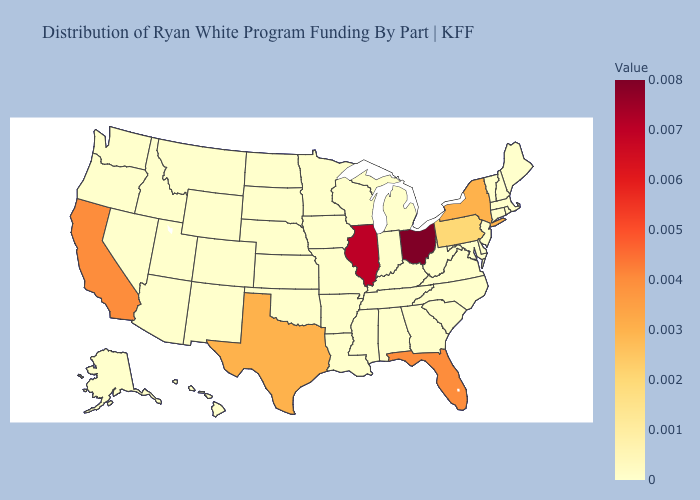Does Illinois have a higher value than West Virginia?
Give a very brief answer. Yes. Does Colorado have the lowest value in the West?
Quick response, please. Yes. 